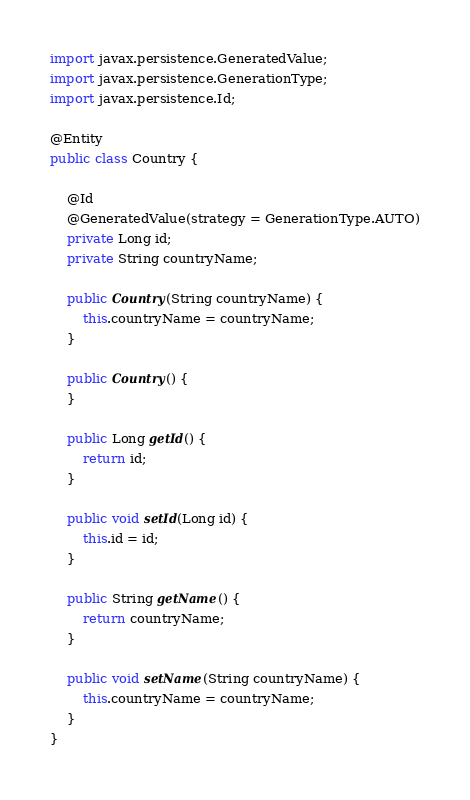<code> <loc_0><loc_0><loc_500><loc_500><_Java_>import javax.persistence.GeneratedValue;
import javax.persistence.GenerationType;
import javax.persistence.Id;

@Entity
public class Country {

    @Id
    @GeneratedValue(strategy = GenerationType.AUTO)
    private Long id;
    private String countryName;

    public Country(String countryName) {
        this.countryName = countryName;
    }

    public Country() {
    }

    public Long getId() {
        return id;
    }

    public void setId(Long id) {
        this.id = id;
    }

    public String getName() {
        return countryName;
    }

    public void setName(String countryName) {
        this.countryName = countryName;
    }
}
</code> 